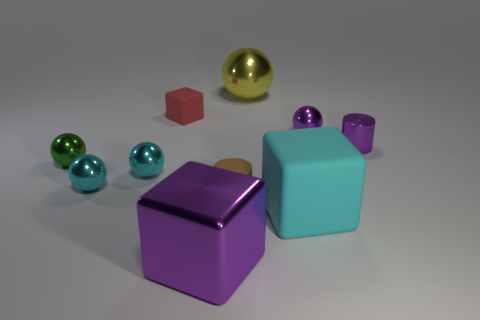The tiny matte cylinder has what color?
Make the answer very short. Brown. Is there anything else of the same color as the large shiny block?
Keep it short and to the point. Yes. Does the purple metal cylinder have the same size as the sphere behind the red rubber thing?
Provide a succinct answer. No. There is a purple shiny object on the left side of the metal ball behind the red matte block; how many big cyan blocks are to the left of it?
Make the answer very short. 0. What is the shape of the brown rubber thing?
Your response must be concise. Cylinder. What number of other things are there of the same material as the tiny green object
Provide a succinct answer. 6. Do the yellow ball and the matte cylinder have the same size?
Give a very brief answer. No. The cyan object to the right of the red thing has what shape?
Provide a succinct answer. Cube. What color is the rubber object in front of the cylinder that is to the left of the big cyan cube?
Provide a succinct answer. Cyan. Do the big shiny object that is on the left side of the big shiny sphere and the small red object that is behind the big matte cube have the same shape?
Your response must be concise. Yes. 